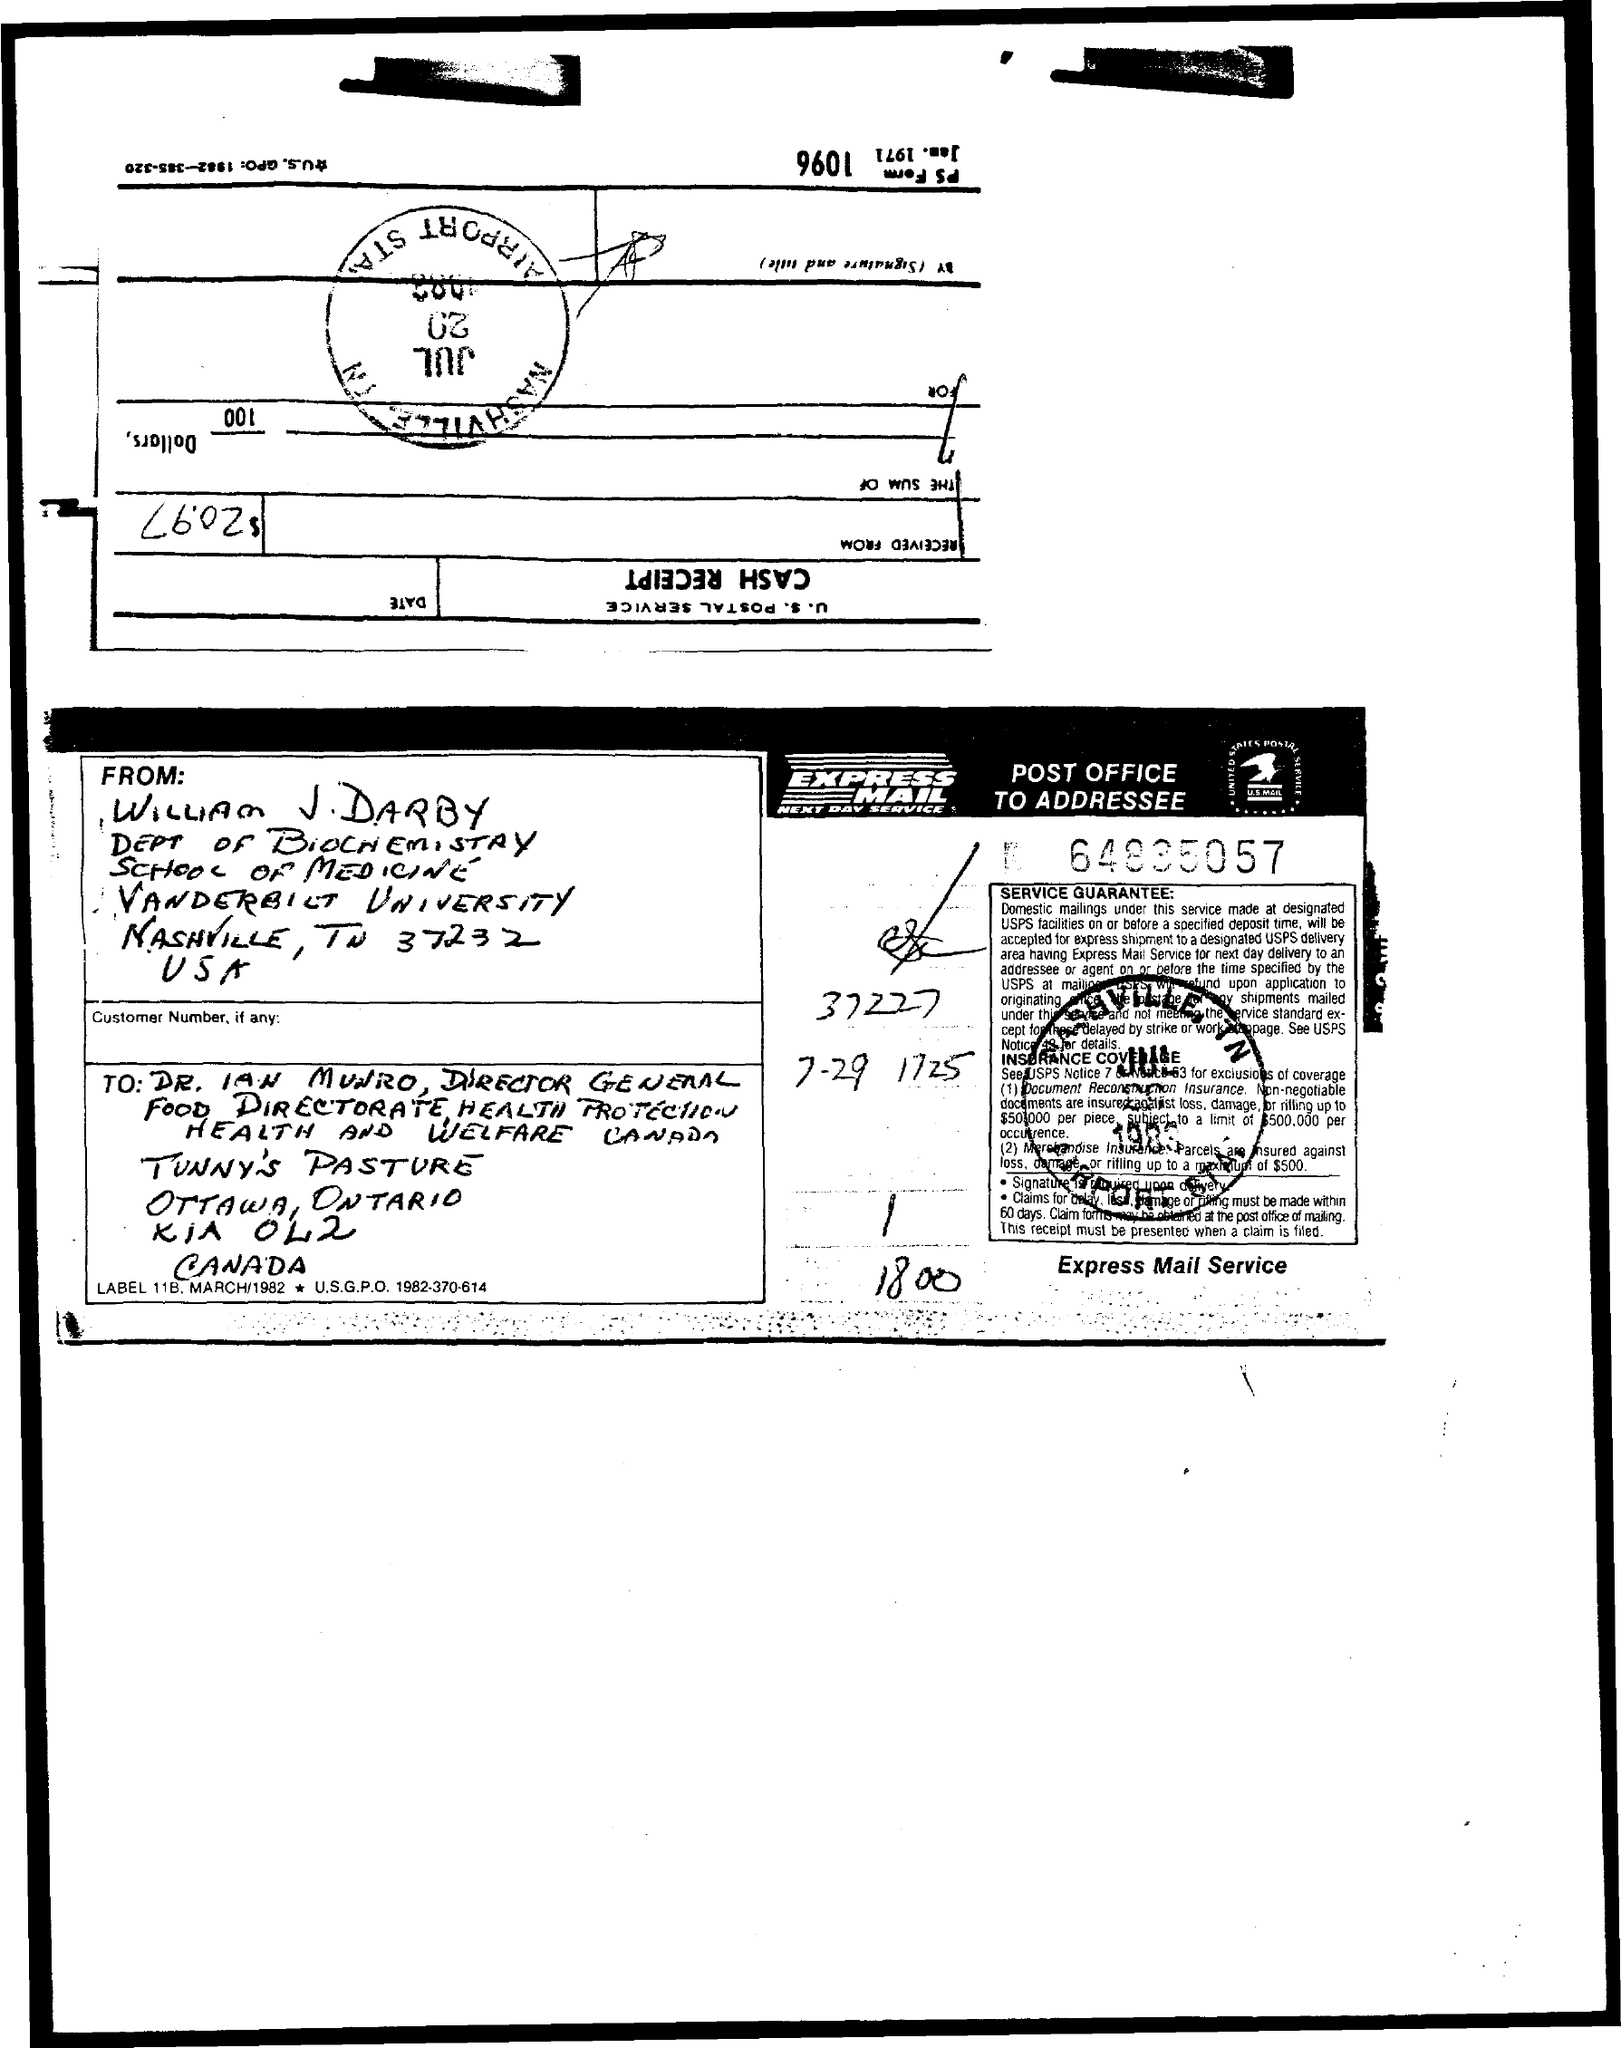Give some essential details in this illustration. The letter was written by William J Darby. William J. Darby is a member of the Department of Biochemistry. The recipient of the email was Dr. Ian Munro. 